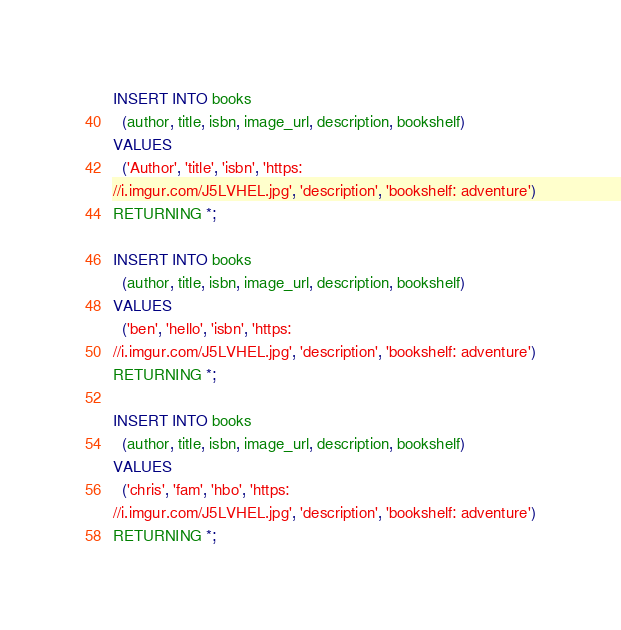<code> <loc_0><loc_0><loc_500><loc_500><_SQL_>INSERT INTO books
  (author, title, isbn, image_url, description, bookshelf)
VALUES
  ('Author', 'title', 'isbn', 'https:
//i.imgur.com/J5LVHEL.jpg', 'description', 'bookshelf: adventure')
RETURNING *;

INSERT INTO books
  (author, title, isbn, image_url, description, bookshelf)
VALUES
  ('ben', 'hello', 'isbn', 'https:
//i.imgur.com/J5LVHEL.jpg', 'description', 'bookshelf: adventure')
RETURNING *;

INSERT INTO books
  (author, title, isbn, image_url, description, bookshelf)
VALUES
  ('chris', 'fam', 'hbo', 'https:
//i.imgur.com/J5LVHEL.jpg', 'description', 'bookshelf: adventure')
RETURNING *;</code> 